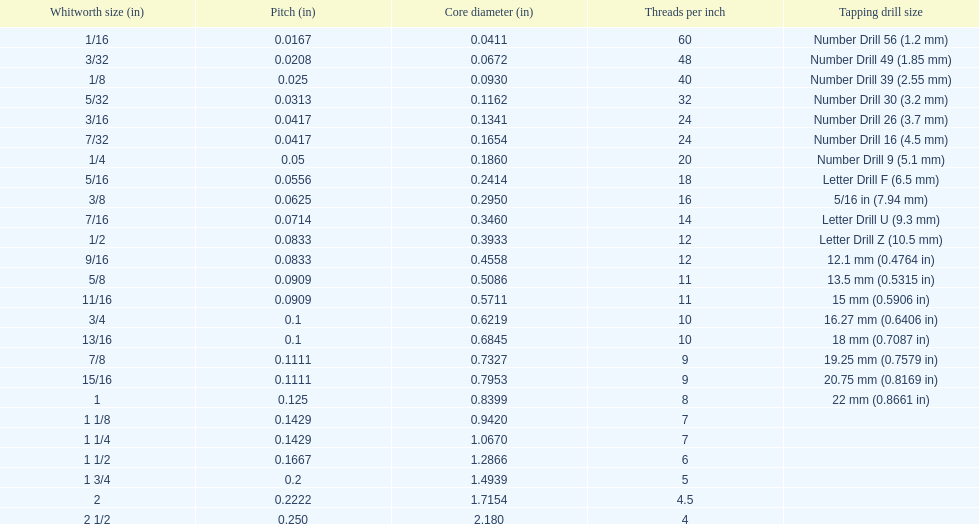What is the total of the first two core diameters? 0.1083. 